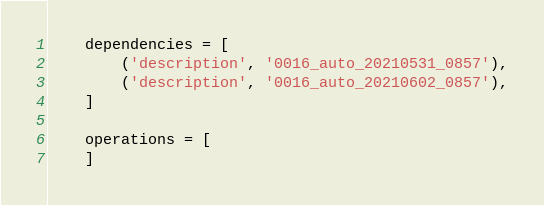Convert code to text. <code><loc_0><loc_0><loc_500><loc_500><_Python_>
    dependencies = [
        ('description', '0016_auto_20210531_0857'),
        ('description', '0016_auto_20210602_0857'),
    ]

    operations = [
    ]
</code> 